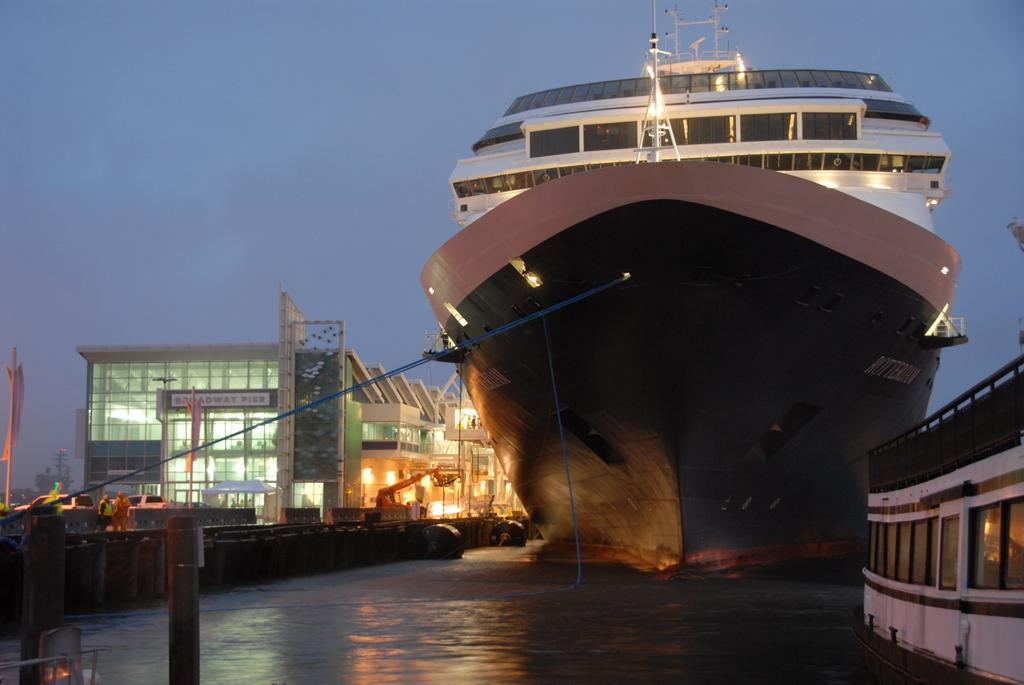<image>
Render a clear and concise summary of the photo. A huge ship that has a sign to the left that says Broadway Pier on it. 